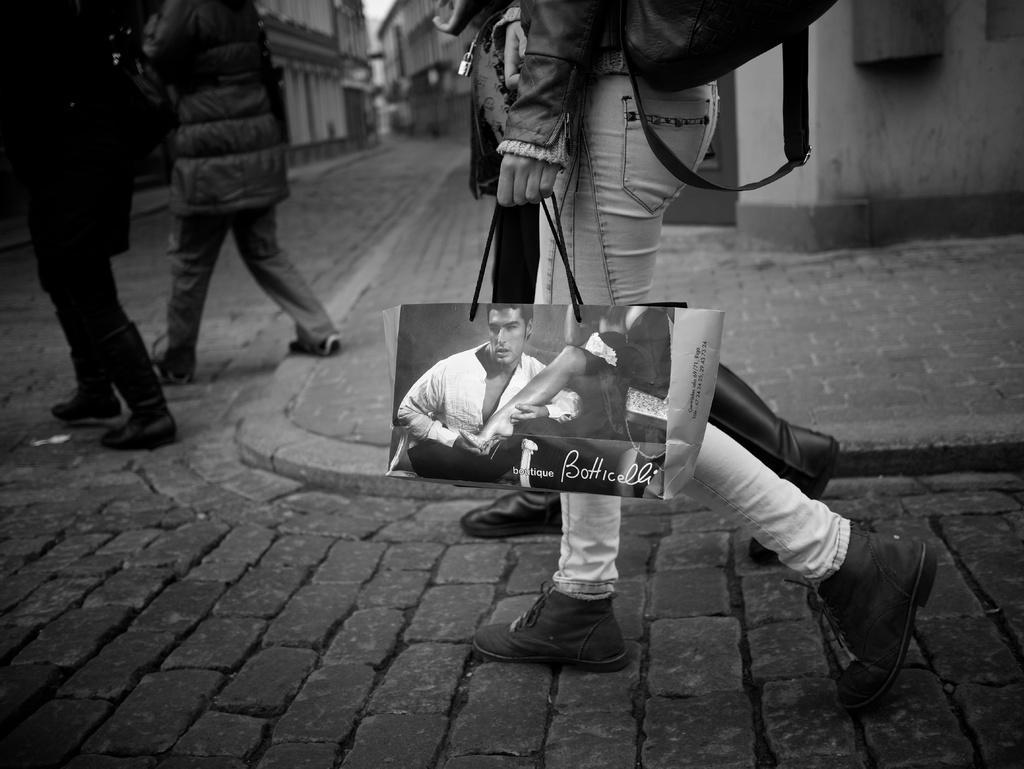Could you give a brief overview of what you see in this image? In this image we can see a black and white picture of a group of persons standing on the ground. One person is carrying a bag and holding another bag in his hand. In the background, we can see a group of buildings, pathways and the sky. 